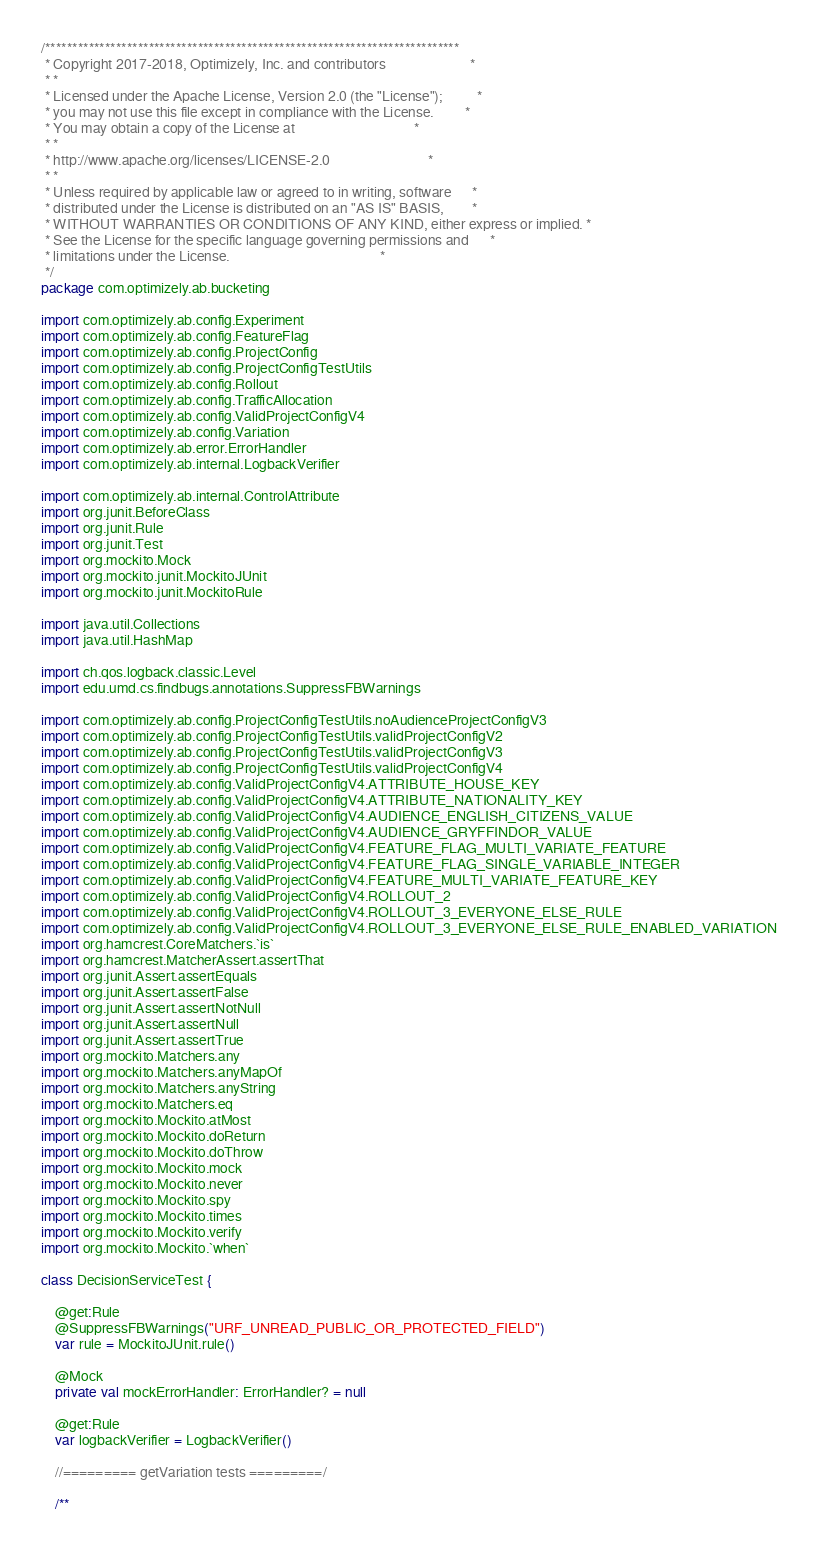Convert code to text. <code><loc_0><loc_0><loc_500><loc_500><_Kotlin_>/****************************************************************************
 * Copyright 2017-2018, Optimizely, Inc. and contributors                        *
 * *
 * Licensed under the Apache License, Version 2.0 (the "License");          *
 * you may not use this file except in compliance with the License.         *
 * You may obtain a copy of the License at                                  *
 * *
 * http://www.apache.org/licenses/LICENSE-2.0                            *
 * *
 * Unless required by applicable law or agreed to in writing, software      *
 * distributed under the License is distributed on an "AS IS" BASIS,        *
 * WITHOUT WARRANTIES OR CONDITIONS OF ANY KIND, either express or implied. *
 * See the License for the specific language governing permissions and      *
 * limitations under the License.                                           *
 */
package com.optimizely.ab.bucketing

import com.optimizely.ab.config.Experiment
import com.optimizely.ab.config.FeatureFlag
import com.optimizely.ab.config.ProjectConfig
import com.optimizely.ab.config.ProjectConfigTestUtils
import com.optimizely.ab.config.Rollout
import com.optimizely.ab.config.TrafficAllocation
import com.optimizely.ab.config.ValidProjectConfigV4
import com.optimizely.ab.config.Variation
import com.optimizely.ab.error.ErrorHandler
import com.optimizely.ab.internal.LogbackVerifier

import com.optimizely.ab.internal.ControlAttribute
import org.junit.BeforeClass
import org.junit.Rule
import org.junit.Test
import org.mockito.Mock
import org.mockito.junit.MockitoJUnit
import org.mockito.junit.MockitoRule

import java.util.Collections
import java.util.HashMap

import ch.qos.logback.classic.Level
import edu.umd.cs.findbugs.annotations.SuppressFBWarnings

import com.optimizely.ab.config.ProjectConfigTestUtils.noAudienceProjectConfigV3
import com.optimizely.ab.config.ProjectConfigTestUtils.validProjectConfigV2
import com.optimizely.ab.config.ProjectConfigTestUtils.validProjectConfigV3
import com.optimizely.ab.config.ProjectConfigTestUtils.validProjectConfigV4
import com.optimizely.ab.config.ValidProjectConfigV4.ATTRIBUTE_HOUSE_KEY
import com.optimizely.ab.config.ValidProjectConfigV4.ATTRIBUTE_NATIONALITY_KEY
import com.optimizely.ab.config.ValidProjectConfigV4.AUDIENCE_ENGLISH_CITIZENS_VALUE
import com.optimizely.ab.config.ValidProjectConfigV4.AUDIENCE_GRYFFINDOR_VALUE
import com.optimizely.ab.config.ValidProjectConfigV4.FEATURE_FLAG_MULTI_VARIATE_FEATURE
import com.optimizely.ab.config.ValidProjectConfigV4.FEATURE_FLAG_SINGLE_VARIABLE_INTEGER
import com.optimizely.ab.config.ValidProjectConfigV4.FEATURE_MULTI_VARIATE_FEATURE_KEY
import com.optimizely.ab.config.ValidProjectConfigV4.ROLLOUT_2
import com.optimizely.ab.config.ValidProjectConfigV4.ROLLOUT_3_EVERYONE_ELSE_RULE
import com.optimizely.ab.config.ValidProjectConfigV4.ROLLOUT_3_EVERYONE_ELSE_RULE_ENABLED_VARIATION
import org.hamcrest.CoreMatchers.`is`
import org.hamcrest.MatcherAssert.assertThat
import org.junit.Assert.assertEquals
import org.junit.Assert.assertFalse
import org.junit.Assert.assertNotNull
import org.junit.Assert.assertNull
import org.junit.Assert.assertTrue
import org.mockito.Matchers.any
import org.mockito.Matchers.anyMapOf
import org.mockito.Matchers.anyString
import org.mockito.Matchers.eq
import org.mockito.Mockito.atMost
import org.mockito.Mockito.doReturn
import org.mockito.Mockito.doThrow
import org.mockito.Mockito.mock
import org.mockito.Mockito.never
import org.mockito.Mockito.spy
import org.mockito.Mockito.times
import org.mockito.Mockito.verify
import org.mockito.Mockito.`when`

class DecisionServiceTest {

    @get:Rule
    @SuppressFBWarnings("URF_UNREAD_PUBLIC_OR_PROTECTED_FIELD")
    var rule = MockitoJUnit.rule()

    @Mock
    private val mockErrorHandler: ErrorHandler? = null

    @get:Rule
    var logbackVerifier = LogbackVerifier()

    //========= getVariation tests =========/

    /**</code> 